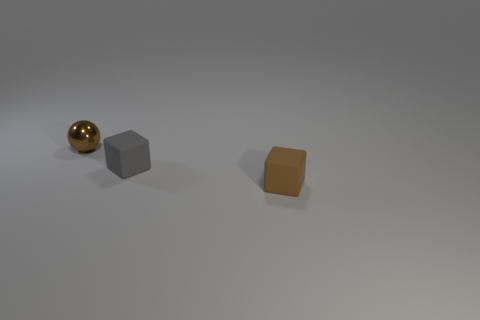Subtract all gray blocks. How many blocks are left? 1 Subtract 1 cubes. How many cubes are left? 1 Add 2 tiny cyan metallic blocks. How many tiny cyan metallic blocks exist? 2 Add 3 tiny red rubber things. How many objects exist? 6 Subtract 0 green cylinders. How many objects are left? 3 Subtract all balls. How many objects are left? 2 Subtract all purple cubes. Subtract all gray cylinders. How many cubes are left? 2 Subtract all yellow spheres. How many gray blocks are left? 1 Subtract all small brown things. Subtract all tiny gray cubes. How many objects are left? 0 Add 3 tiny brown spheres. How many tiny brown spheres are left? 4 